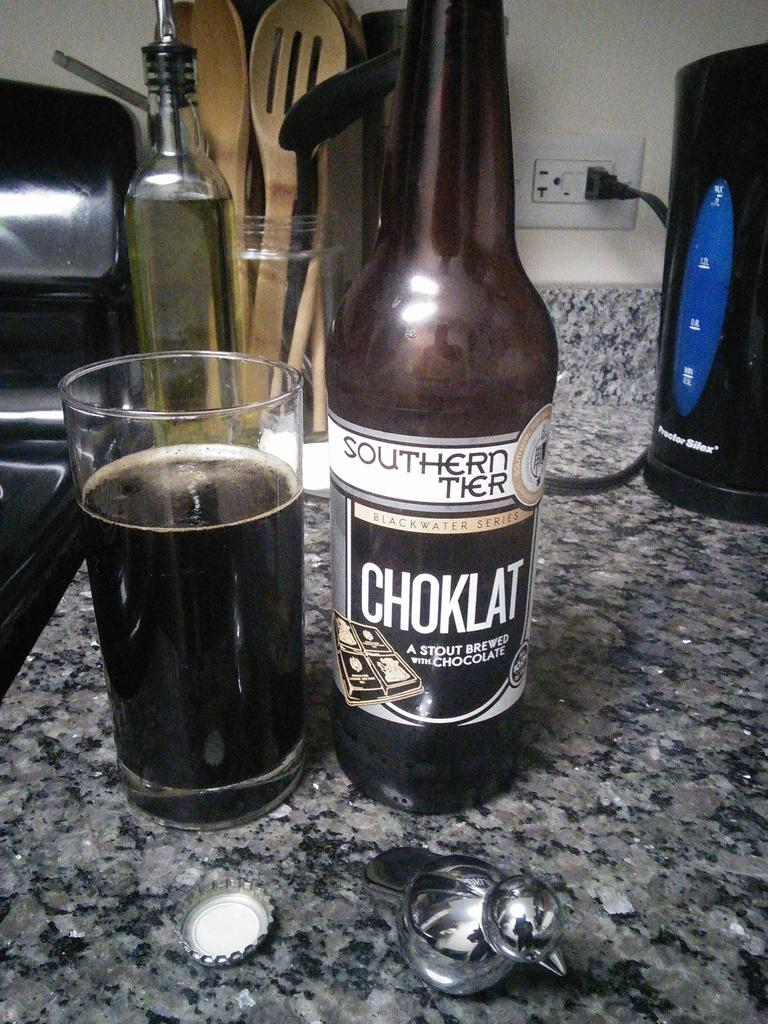<image>
Offer a succinct explanation of the picture presented. Sitting on a marble, top table is a bottle of Choklate, stout brewed  ale is shown, along with a glass of the ale. 